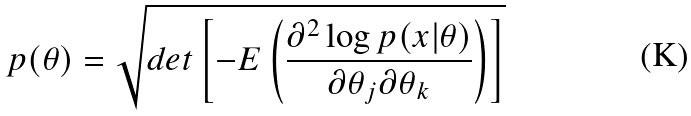Convert formula to latex. <formula><loc_0><loc_0><loc_500><loc_500>p ( \theta ) = \sqrt { d e t \left [ - E \left ( \frac { \partial ^ { 2 } \log p ( x | \theta ) } { \partial \theta _ { j } \partial \theta _ { k } } \right ) \right ] } \\</formula> 